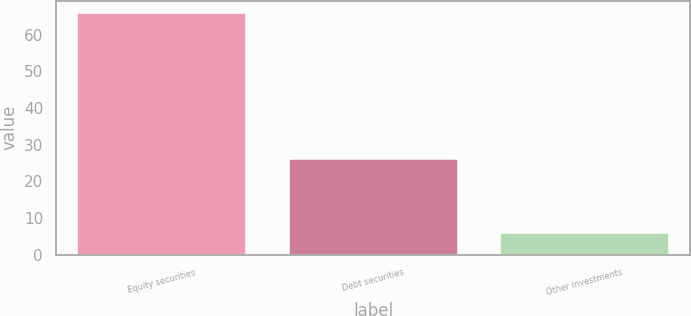Convert chart to OTSL. <chart><loc_0><loc_0><loc_500><loc_500><bar_chart><fcel>Equity securities<fcel>Debt securities<fcel>Other investments<nl><fcel>66<fcel>26<fcel>6<nl></chart> 